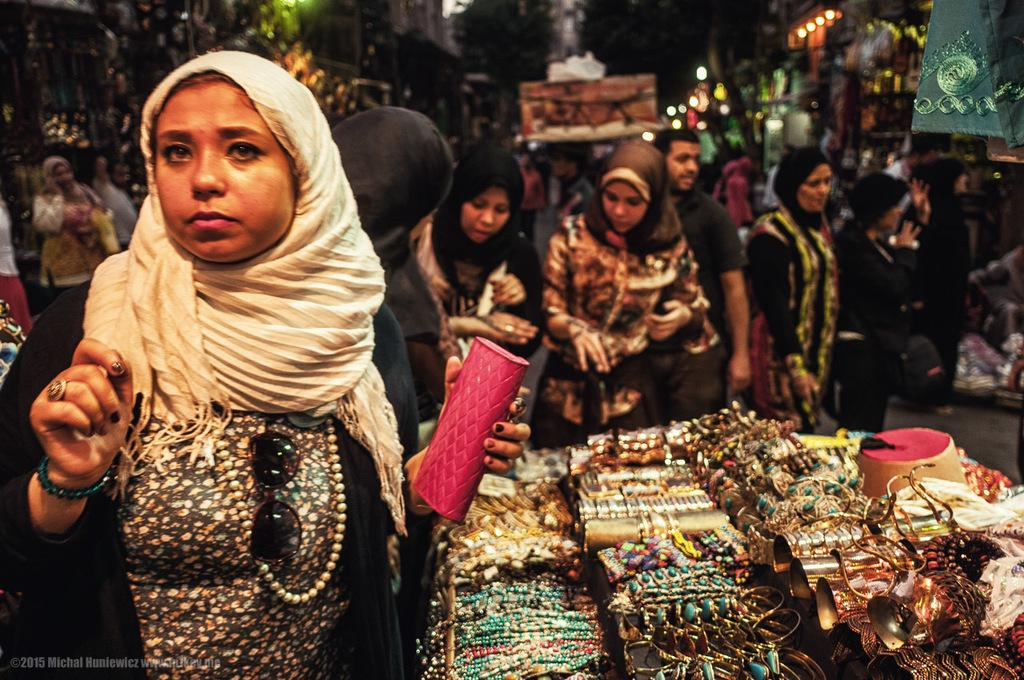What is the woman on the left side of the image holding? The woman is holding a purse on the left side of the image. What can be seen in the middle of the image? There are buildings, lights, and a group of people in the middle of the image. What is located at the bottom of the image? There are objects visible at the bottom of the image. What type of profit can be seen growing in the image? There is no profit visible in the image, as profit is a financial concept and not a physical object that can be seen in an image. 